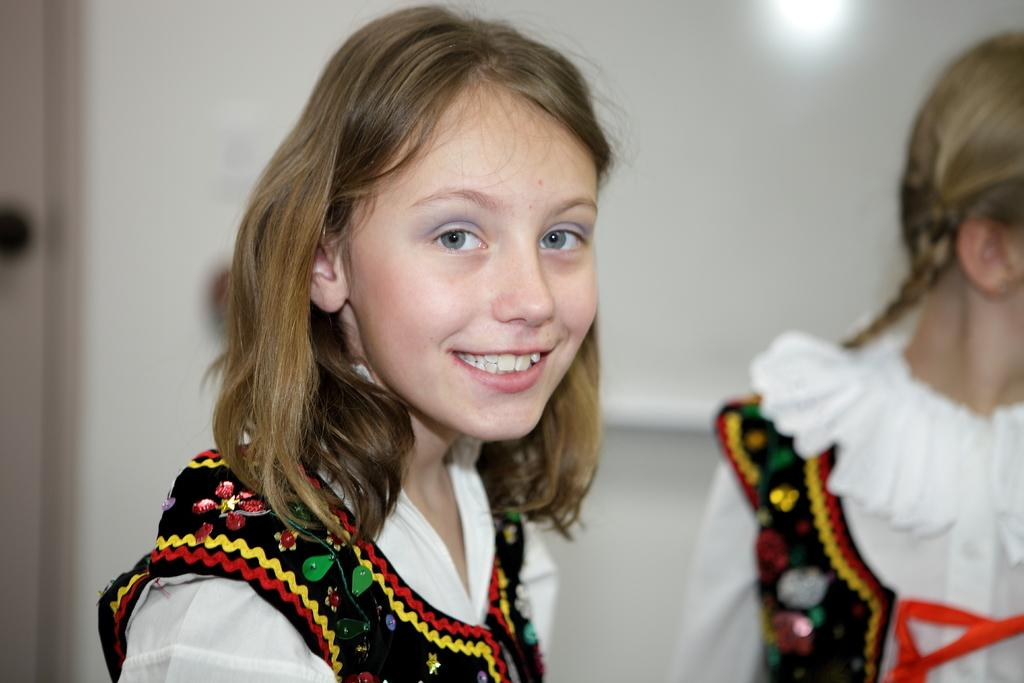How many people are present in the image? There are two girls in the image. What can be seen in the background of the image? There is a white color wall in the background of the image. What type of butter is being used by the girls in the image? There is no butter present in the image. How does the locket affect the girls' nerves in the image? There is no locket or mention of nerves in the image. 